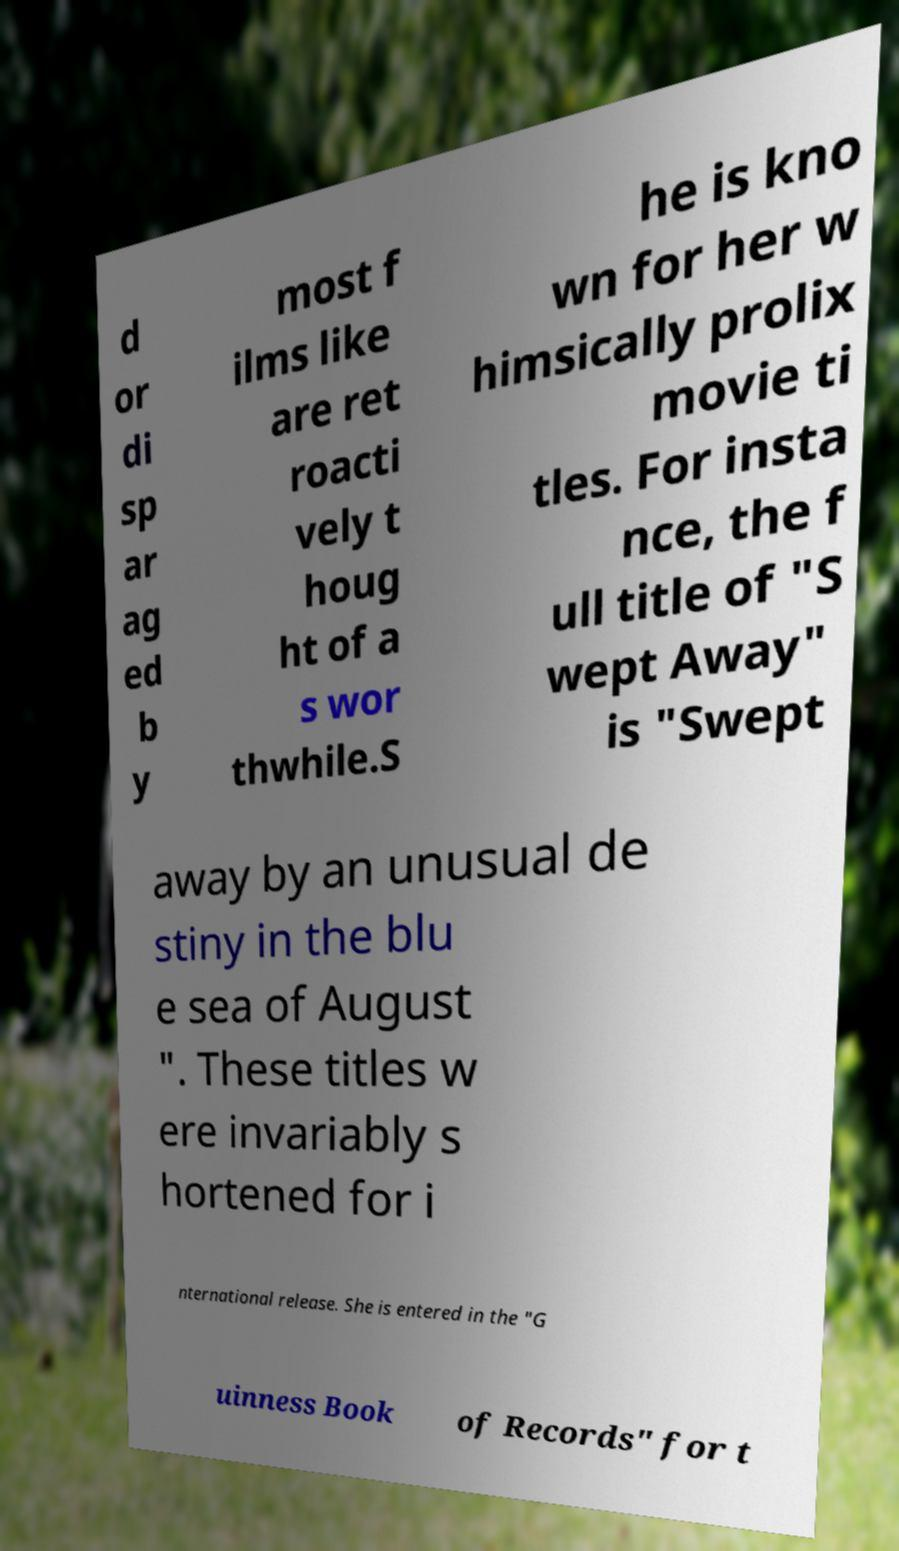Can you read and provide the text displayed in the image?This photo seems to have some interesting text. Can you extract and type it out for me? d or di sp ar ag ed b y most f ilms like are ret roacti vely t houg ht of a s wor thwhile.S he is kno wn for her w himsically prolix movie ti tles. For insta nce, the f ull title of "S wept Away" is "Swept away by an unusual de stiny in the blu e sea of August ". These titles w ere invariably s hortened for i nternational release. She is entered in the "G uinness Book of Records" for t 